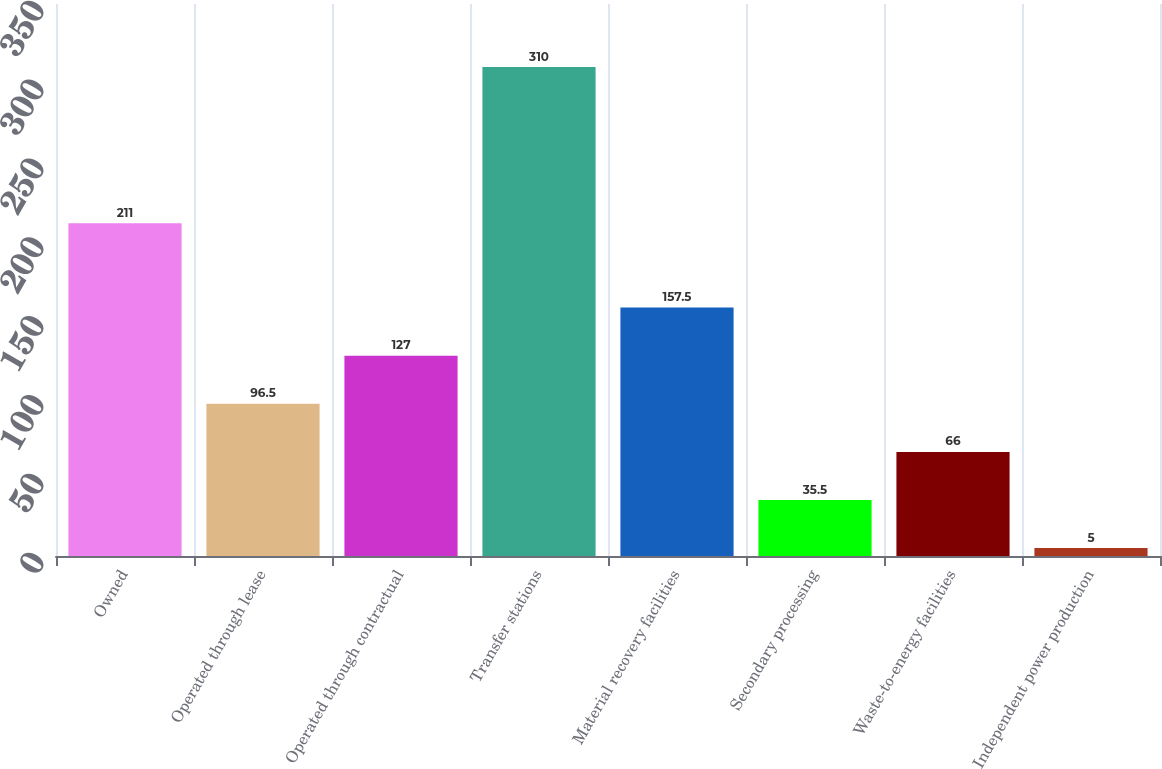Convert chart. <chart><loc_0><loc_0><loc_500><loc_500><bar_chart><fcel>Owned<fcel>Operated through lease<fcel>Operated through contractual<fcel>Transfer stations<fcel>Material recovery facilities<fcel>Secondary processing<fcel>Waste-to-energy facilities<fcel>Independent power production<nl><fcel>211<fcel>96.5<fcel>127<fcel>310<fcel>157.5<fcel>35.5<fcel>66<fcel>5<nl></chart> 